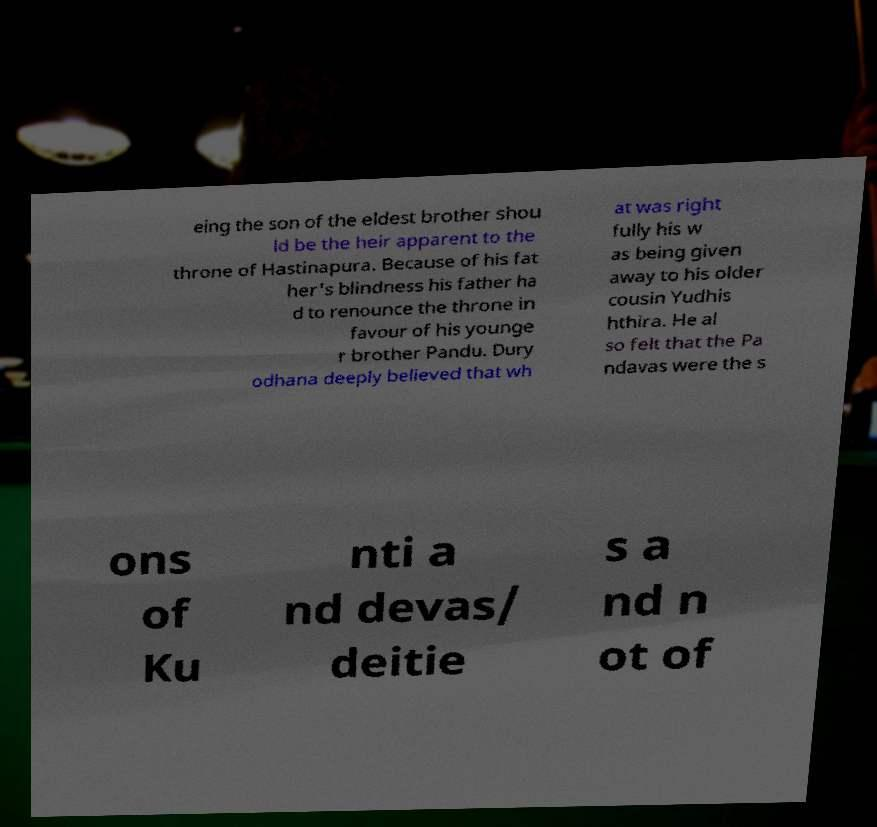Could you assist in decoding the text presented in this image and type it out clearly? eing the son of the eldest brother shou ld be the heir apparent to the throne of Hastinapura. Because of his fat her's blindness his father ha d to renounce the throne in favour of his younge r brother Pandu. Dury odhana deeply believed that wh at was right fully his w as being given away to his older cousin Yudhis hthira. He al so felt that the Pa ndavas were the s ons of Ku nti a nd devas/ deitie s a nd n ot of 